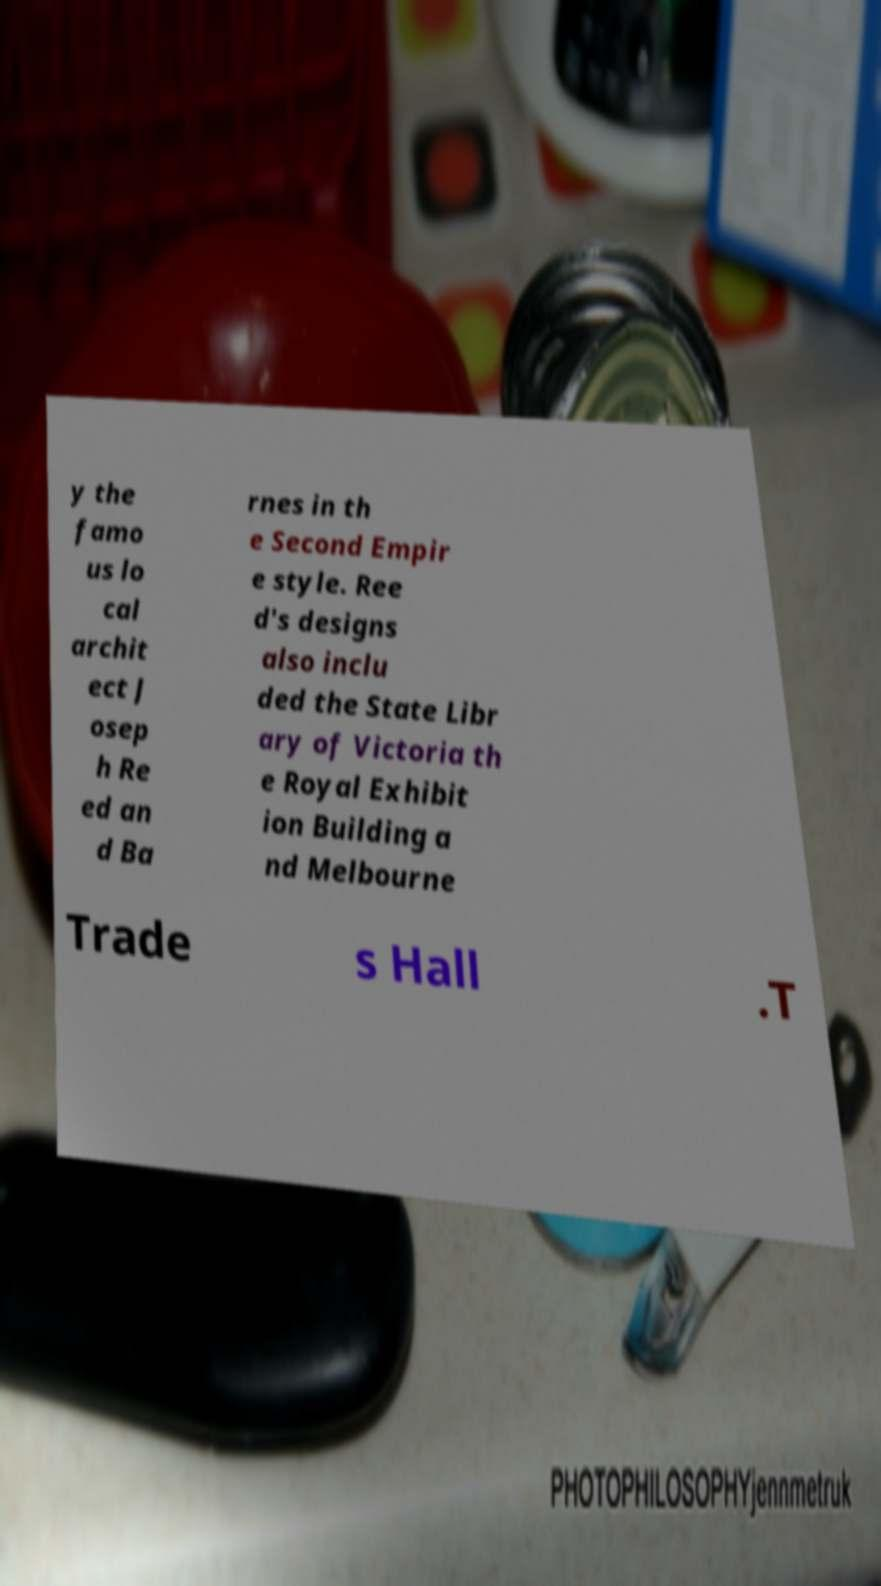Can you read and provide the text displayed in the image?This photo seems to have some interesting text. Can you extract and type it out for me? y the famo us lo cal archit ect J osep h Re ed an d Ba rnes in th e Second Empir e style. Ree d's designs also inclu ded the State Libr ary of Victoria th e Royal Exhibit ion Building a nd Melbourne Trade s Hall .T 